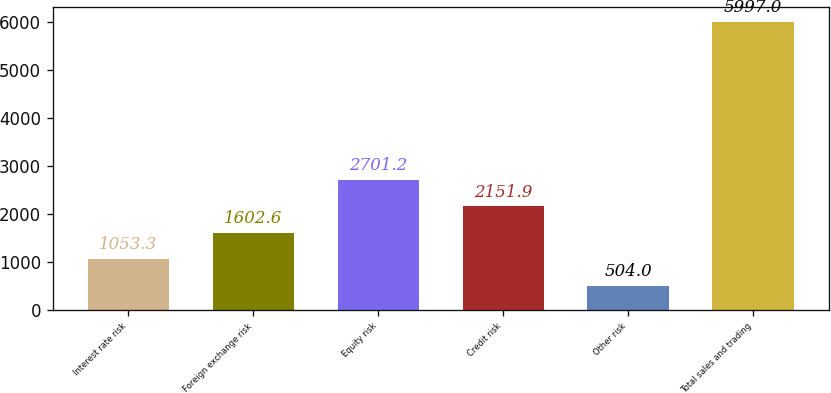Convert chart to OTSL. <chart><loc_0><loc_0><loc_500><loc_500><bar_chart><fcel>Interest rate risk<fcel>Foreign exchange risk<fcel>Equity risk<fcel>Credit risk<fcel>Other risk<fcel>Total sales and trading<nl><fcel>1053.3<fcel>1602.6<fcel>2701.2<fcel>2151.9<fcel>504<fcel>5997<nl></chart> 